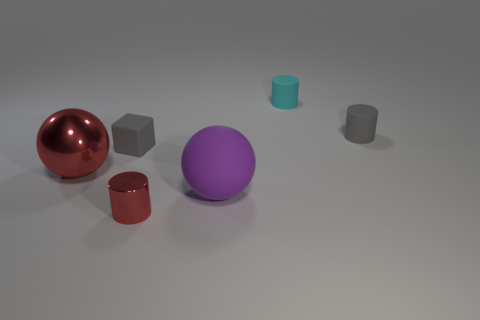Add 2 gray rubber cylinders. How many objects exist? 8 Subtract all balls. How many objects are left? 4 Subtract all gray matte objects. Subtract all large metal things. How many objects are left? 3 Add 4 rubber balls. How many rubber balls are left? 5 Add 5 gray things. How many gray things exist? 7 Subtract 0 cyan blocks. How many objects are left? 6 